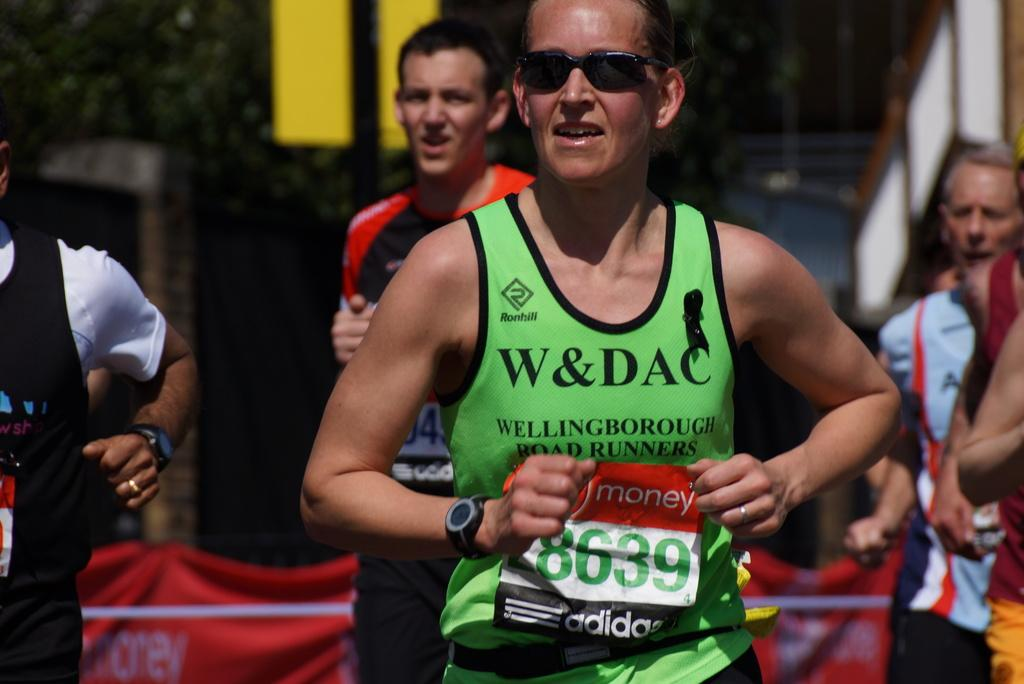<image>
Present a compact description of the photo's key features. Runner number 8639 is wearing a green shirt that says W&DAC. 